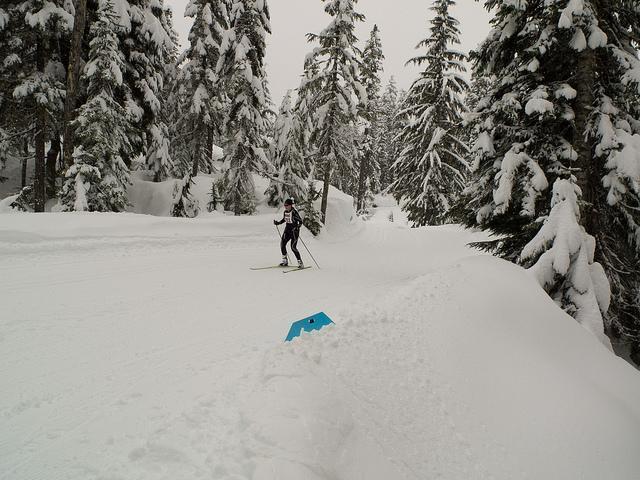How many people are shown?
Give a very brief answer. 1. How many dogs are there left to the lady?
Give a very brief answer. 0. 